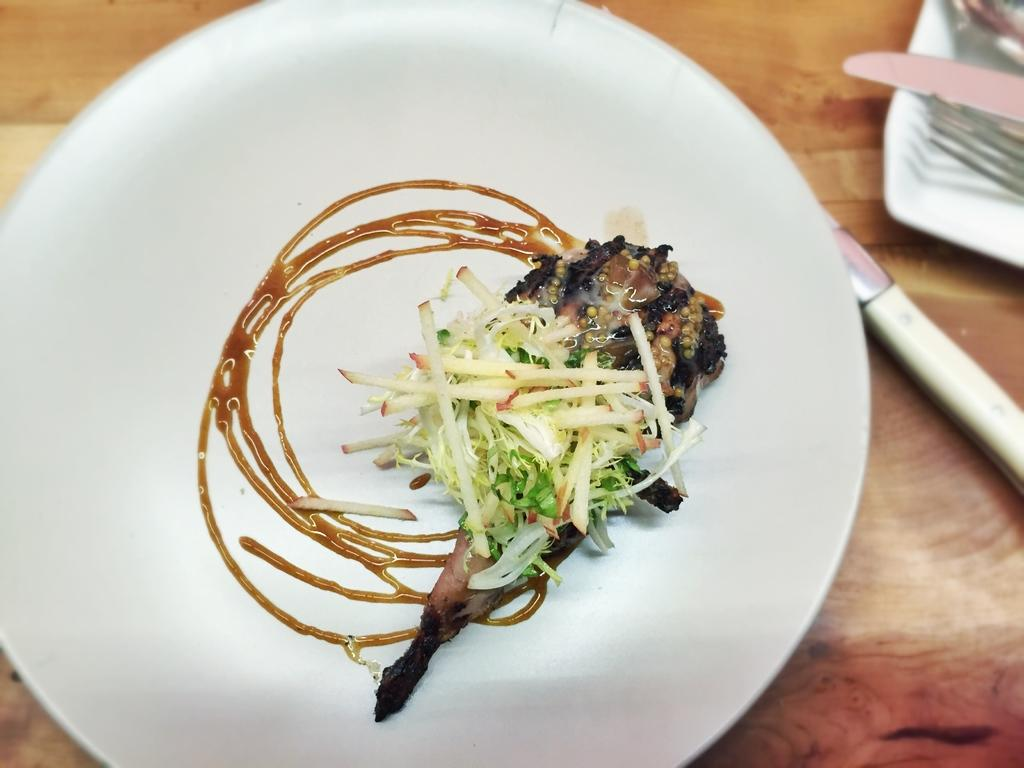What is on the plate in the image? There is a food item on a plate in the image. What utensils can be seen in the image? Knives and a fork are visible in the image. What type of material is the wooden object made of? The wooden object in the image is made of wood. What news headline is visible on the food item in the image? There is no news headline present on the food item in the image; it is simply a food item on a plate. 